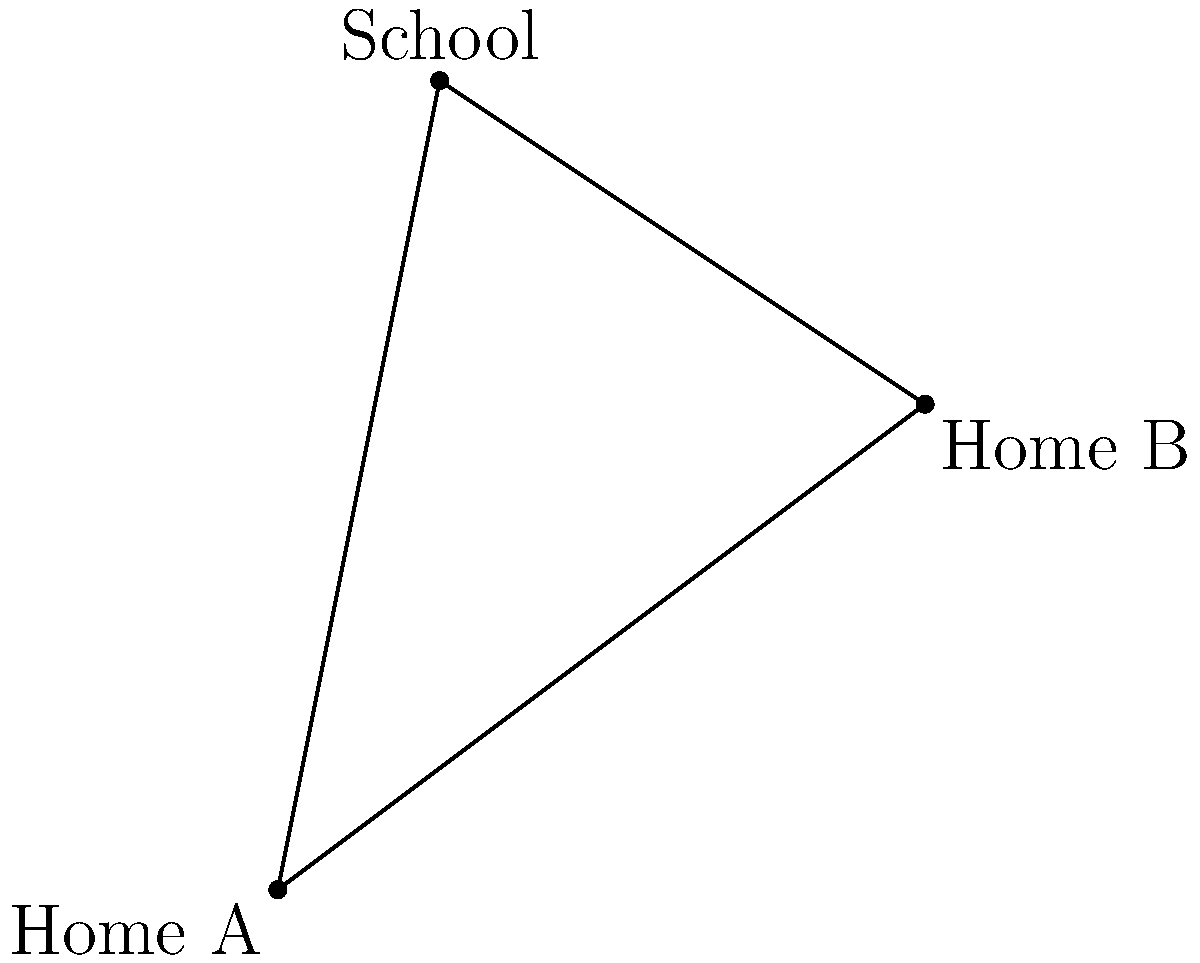As a concerned parent in South Roxana, you want to calculate the distance between your home (Home A) and your child's friend's home (Home B) on a simple town map. The map shows both homes and the school forming a triangle. If the distance from Home A to the school is 5.1 miles, and the distance from Home B to the school is 3.6 miles, what is the distance between Home A and Home B? To solve this problem, we can use the Pythagorean theorem. Let's follow these steps:

1) First, we need to identify the triangle formed by the two homes and the school. Let's call the distance between Home A and Home B as $c$.

2) We know that:
   - The distance from Home A to the school is 5.1 miles (let's call this $a$)
   - The distance from Home B to the school is 3.6 miles (let's call this $b$)

3) Using the Pythagorean theorem, we can write:

   $a^2 + b^2 = c^2$

4) Substituting the known values:

   $5.1^2 + 3.6^2 = c^2$

5) Let's calculate:
   
   $26.01 + 12.96 = c^2$
   $38.97 = c^2$

6) To find $c$, we need to take the square root of both sides:

   $c = \sqrt{38.97}$

7) Using a calculator or computer:

   $c \approx 6.24$ miles

Therefore, the distance between Home A and Home B is approximately 6.24 miles.
Answer: 6.24 miles 